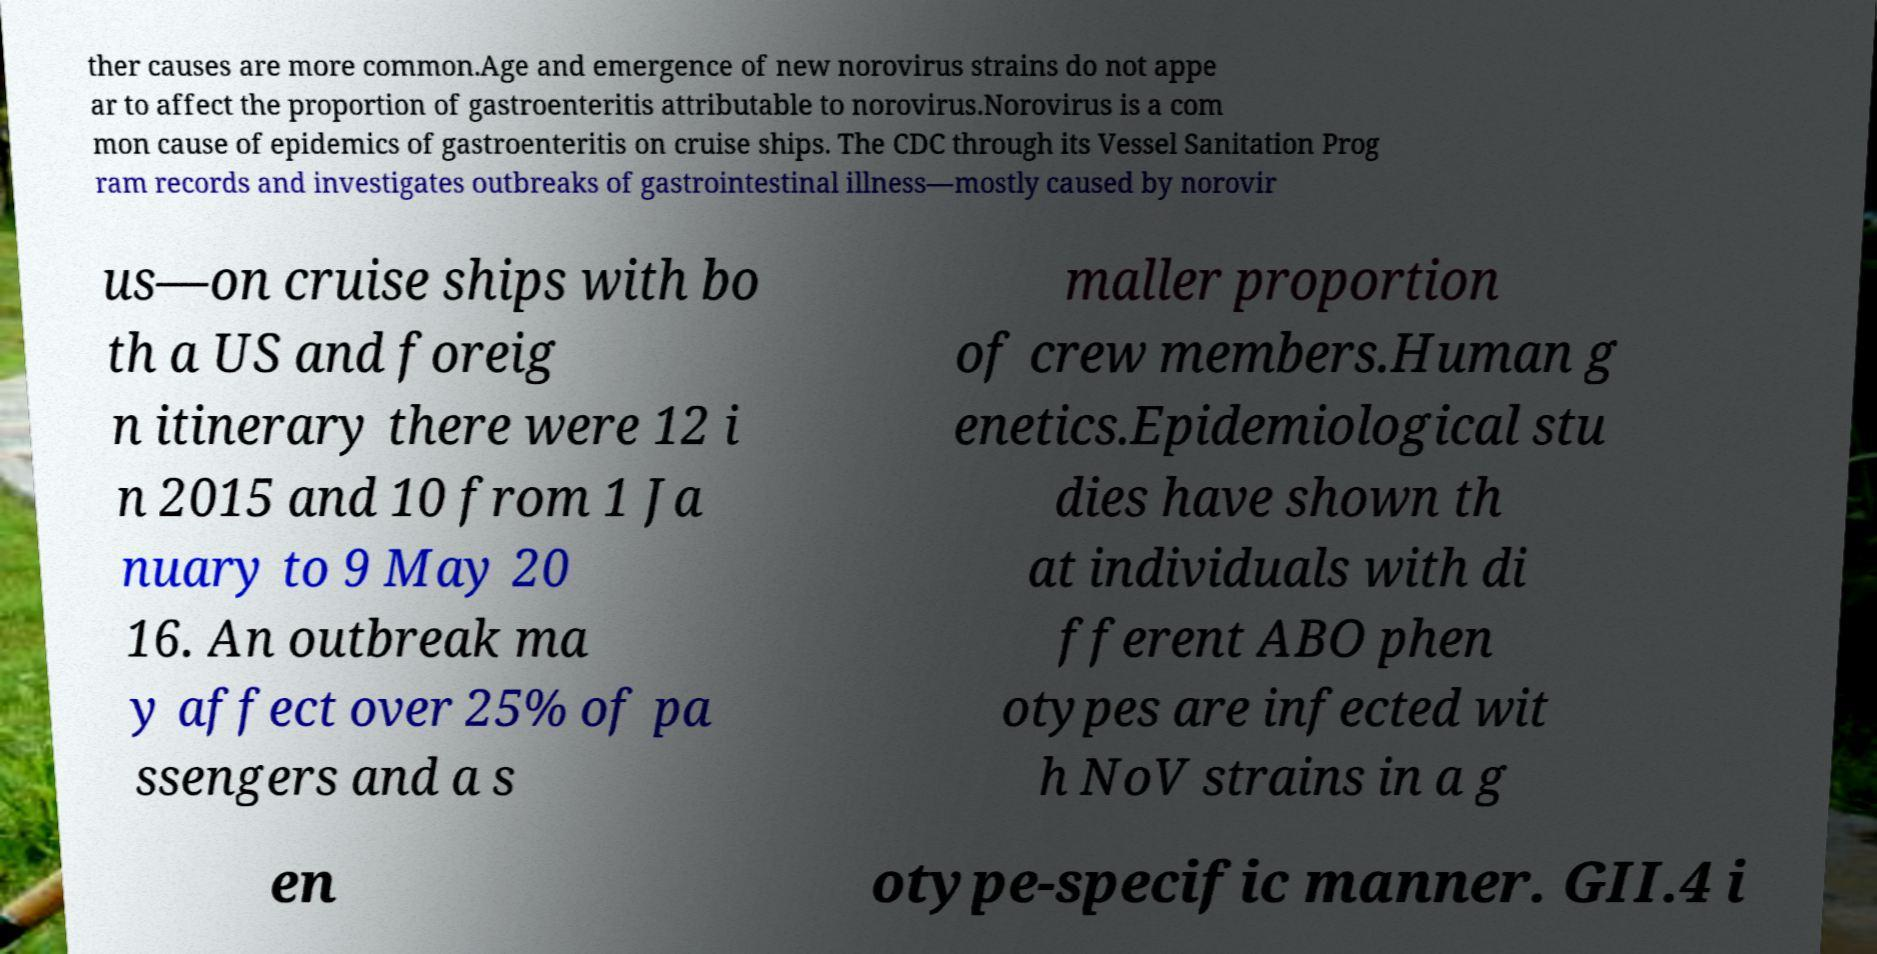I need the written content from this picture converted into text. Can you do that? ther causes are more common.Age and emergence of new norovirus strains do not appe ar to affect the proportion of gastroenteritis attributable to norovirus.Norovirus is a com mon cause of epidemics of gastroenteritis on cruise ships. The CDC through its Vessel Sanitation Prog ram records and investigates outbreaks of gastrointestinal illness—mostly caused by norovir us—on cruise ships with bo th a US and foreig n itinerary there were 12 i n 2015 and 10 from 1 Ja nuary to 9 May 20 16. An outbreak ma y affect over 25% of pa ssengers and a s maller proportion of crew members.Human g enetics.Epidemiological stu dies have shown th at individuals with di fferent ABO phen otypes are infected wit h NoV strains in a g en otype-specific manner. GII.4 i 